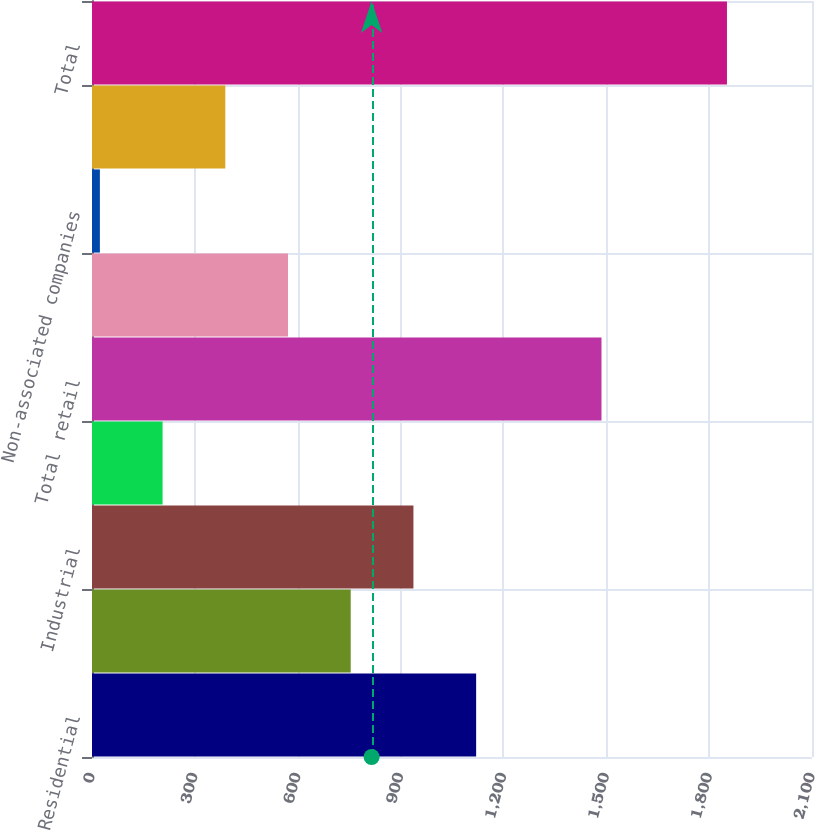<chart> <loc_0><loc_0><loc_500><loc_500><bar_chart><fcel>Residential<fcel>Commercial<fcel>Industrial<fcel>Governmental<fcel>Total retail<fcel>Associated companies<fcel>Non-associated companies<fcel>Other<fcel>Total<nl><fcel>1120.4<fcel>754.6<fcel>937.5<fcel>205.9<fcel>1486<fcel>571.7<fcel>23<fcel>388.8<fcel>1852<nl></chart> 